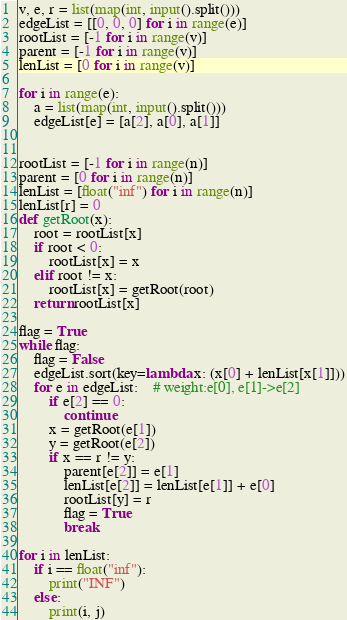<code> <loc_0><loc_0><loc_500><loc_500><_Python_>v, e, r = list(map(int, input().split()))
edgeList = [[0, 0, 0] for i in range(e)]
rootList = [-1 for i in range(v)]
parent = [-1 for i in range(v)]
lenList = [0 for i in range(v)]

for i in range(e):
    a = list(map(int, input().split()))
    edgeList[e] = [a[2], a[0], a[1]]
 
 
rootList = [-1 for i in range(n)]
parent = [0 for i in range(n)]
lenList = [float("inf") for i in range(n)]
lenList[r] = 0
def getRoot(x):
    root = rootList[x]
    if root < 0:
        rootList[x] = x
    elif root != x:
        rootList[x] = getRoot(root)
    return rootList[x]
 
flag = True
while flag:
    flag = False
    edgeList.sort(key=lambda x: (x[0] + lenList[x[1]]))
    for e in edgeList:    # weight:e[0], e[1]->e[2]
        if e[2] == 0:
            continue
        x = getRoot(e[1])
        y = getRoot(e[2])
        if x == r != y:
            parent[e[2]] = e[1]
            lenList[e[2]] = lenList[e[1]] + e[0]
            rootList[y] = r
            flag = True
            break
 
for i in lenList:
    if i == float("inf"):
        print("INF")
    else:
        print(i, j)</code> 